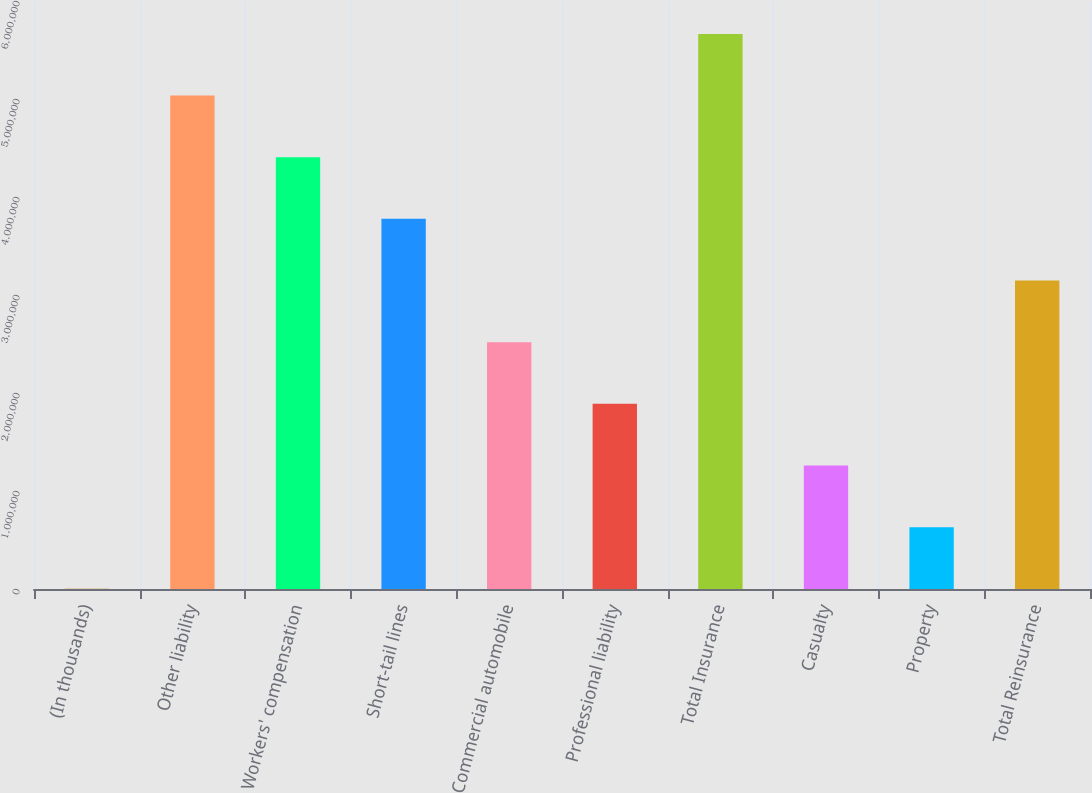Convert chart to OTSL. <chart><loc_0><loc_0><loc_500><loc_500><bar_chart><fcel>(In thousands)<fcel>Other liability<fcel>Workers' compensation<fcel>Short-tail lines<fcel>Commercial automobile<fcel>Professional liability<fcel>Total Insurance<fcel>Casualty<fcel>Property<fcel>Total Reinsurance<nl><fcel>2016<fcel>5.03508e+06<fcel>4.40595e+06<fcel>3.77682e+06<fcel>2.51855e+06<fcel>1.88942e+06<fcel>5.66421e+06<fcel>1.26028e+06<fcel>631149<fcel>3.14768e+06<nl></chart> 